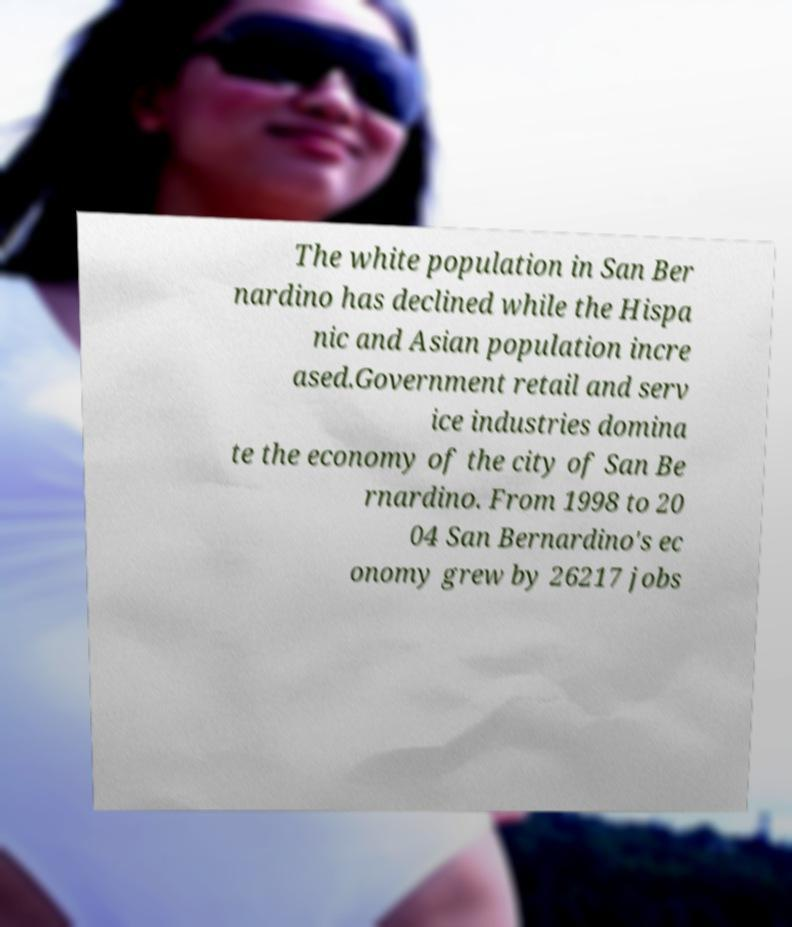Please read and relay the text visible in this image. What does it say? The white population in San Ber nardino has declined while the Hispa nic and Asian population incre ased.Government retail and serv ice industries domina te the economy of the city of San Be rnardino. From 1998 to 20 04 San Bernardino's ec onomy grew by 26217 jobs 